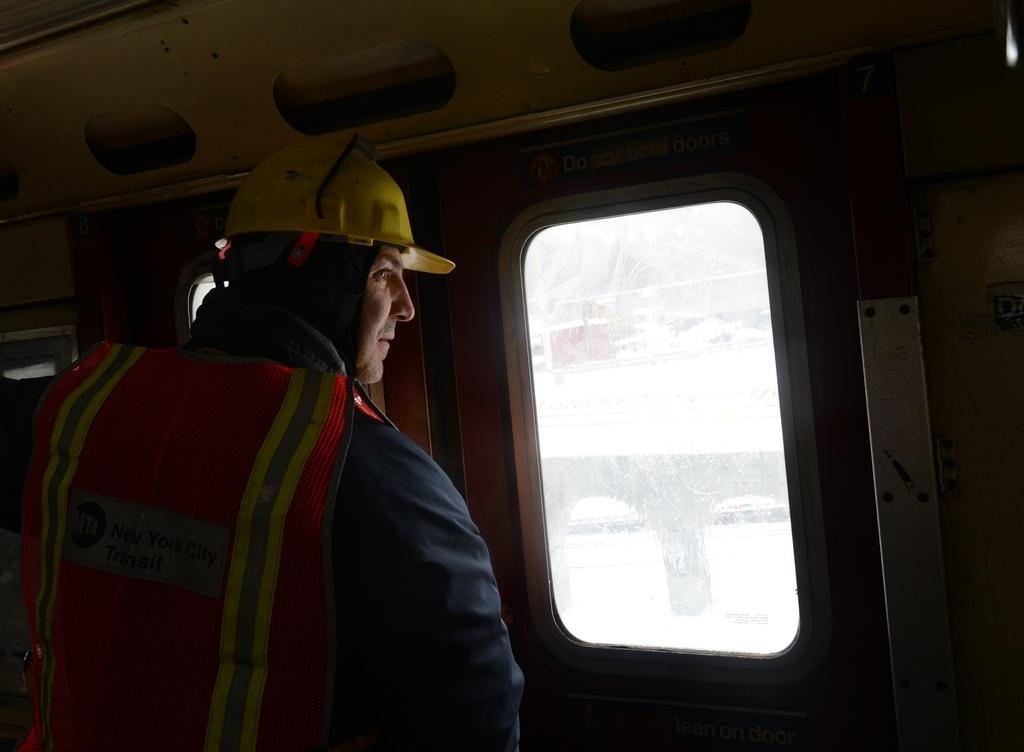Describe this image in one or two sentences. In this image there is a person looking through the window of a vehicle, outside the window there is a bridge. 